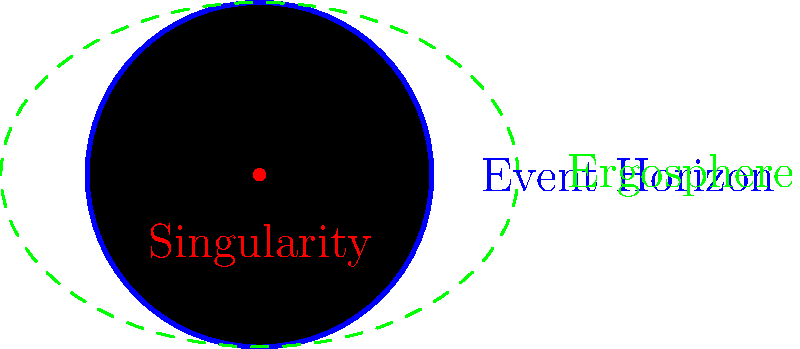In the cross-sectional diagram of a black hole, what is the region between the event horizon and the ergosphere called, and what unique property does it exhibit that relates to the ethical considerations in financial decision-making? To answer this question, let's break it down step-by-step:

1. Identify the components in the diagram:
   - The black circle represents the black hole itself.
   - The blue circle is the event horizon.
   - The green dashed line represents the ergosphere.
   - The red dot at the center is the singularity.

2. The region between the event horizon and the ergosphere:
   This region is called the "static limit" or "stationary limit."

3. Unique property of this region:
   In the static limit, space-time is dragged around the black hole in a process called "frame-dragging" or the "Lense-Thirring effect."

4. Relating to ethical considerations in financial decision-making:
   The static limit can be analogous to a "gray area" in finance where ethical decisions become complex:
   a) Just as objects in the static limit can still escape the black hole but are strongly influenced by its gravity, financial decisions in ethical gray areas may not be strictly illegal but can be heavily influenced by conflicting interests.
   b) The frame-dragging effect is similar to how market forces or corporate culture can "drag" decision-makers towards certain actions, even if they're ethically questionable.
   c) Understanding this region emphasizes the importance of having strong ethical guidelines and governance structures in place, much like how understanding the physics of black holes requires robust theoretical frameworks.

5. Ethical implications:
   - Transparency: Just as the static limit is a crucial area for understanding black hole dynamics, identifying and being transparent about potential conflict areas is vital in finance.
   - Risk management: The complex behavior in the static limit mirrors the need for sophisticated risk assessment in ethically ambiguous financial situations.
   - Corporate governance: Strong governance structures are necessary to navigate these "gray areas," much like how advanced physics is needed to describe the behavior near a black hole.
Answer: Static limit; exhibits frame-dragging, analogous to ethical gray areas in finance 